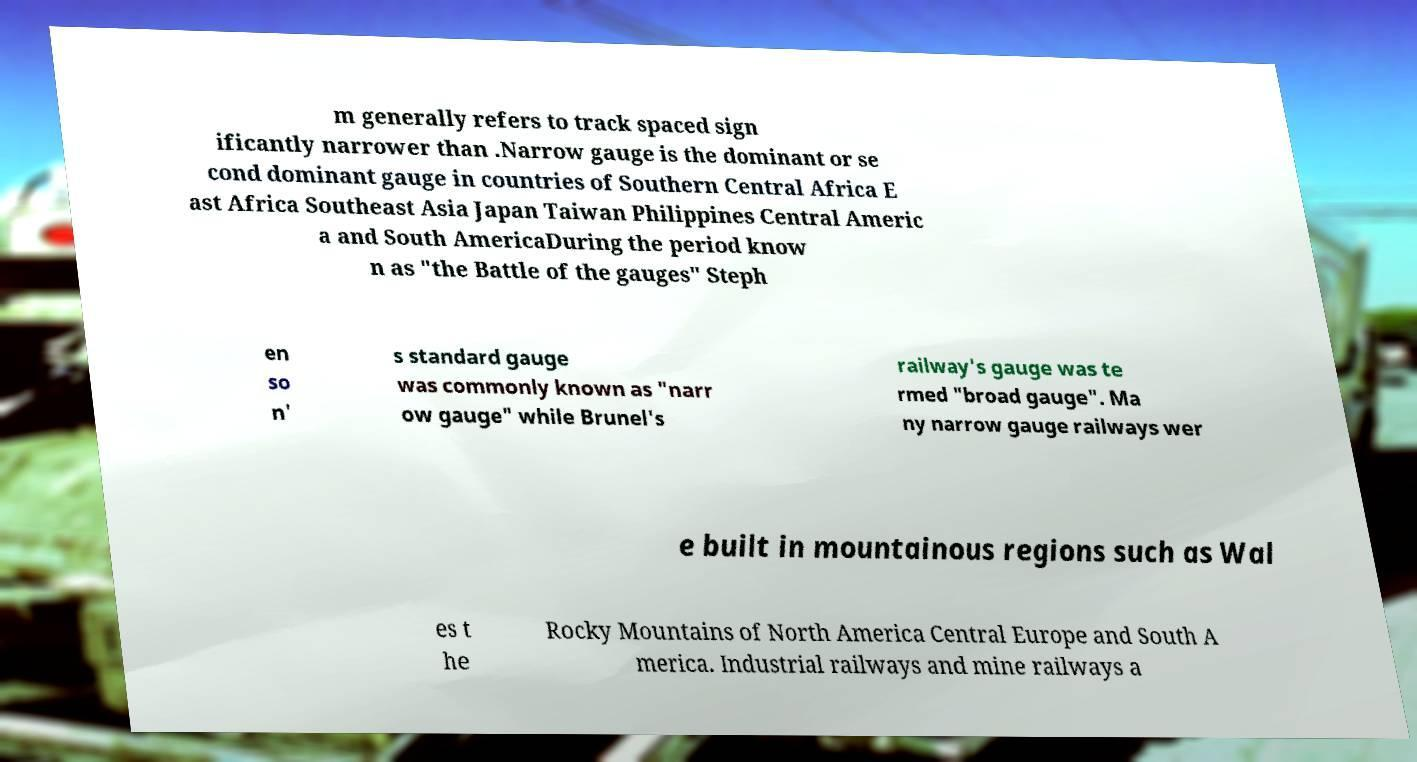Please read and relay the text visible in this image. What does it say? m generally refers to track spaced sign ificantly narrower than .Narrow gauge is the dominant or se cond dominant gauge in countries of Southern Central Africa E ast Africa Southeast Asia Japan Taiwan Philippines Central Americ a and South AmericaDuring the period know n as "the Battle of the gauges" Steph en so n' s standard gauge was commonly known as "narr ow gauge" while Brunel's railway's gauge was te rmed "broad gauge". Ma ny narrow gauge railways wer e built in mountainous regions such as Wal es t he Rocky Mountains of North America Central Europe and South A merica. Industrial railways and mine railways a 